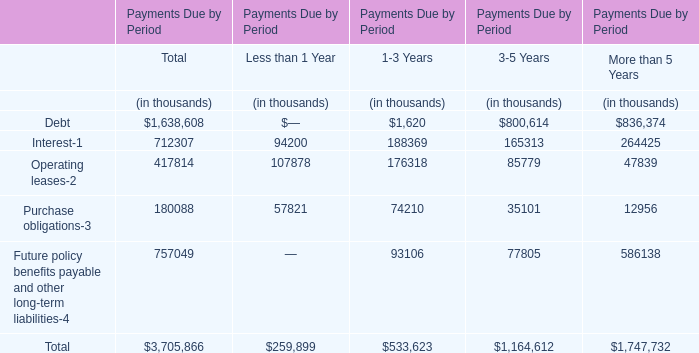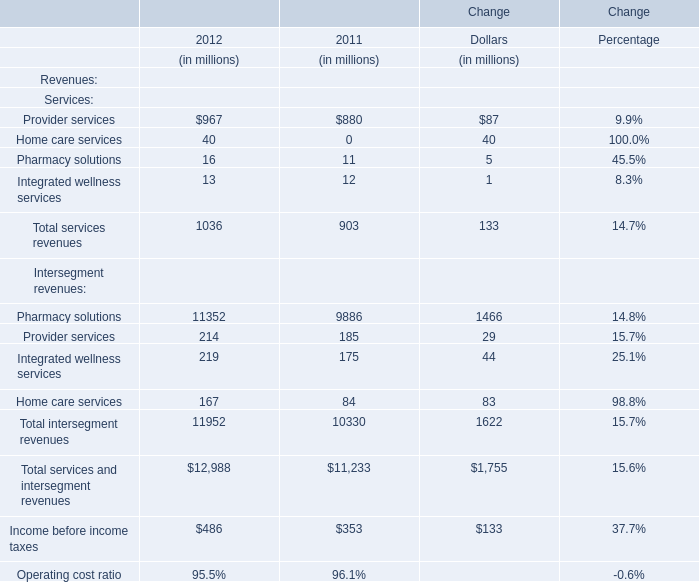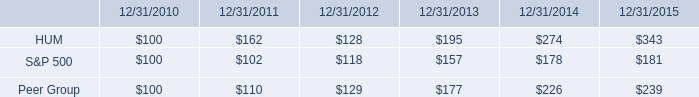What was the average value of the ntersegment revenues: Pharmacy solutions in the years where Services: Provider services positive? (in million) 
Computations: ((11352 + 9886) / 2)
Answer: 10619.0. 